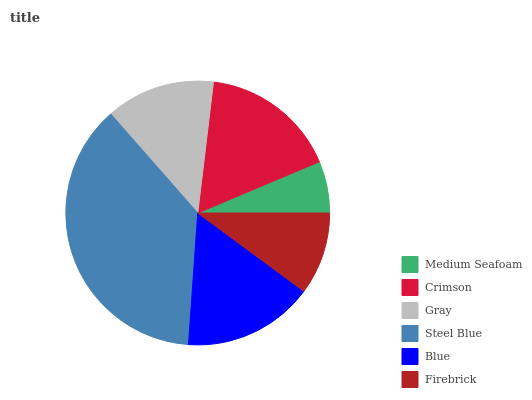Is Medium Seafoam the minimum?
Answer yes or no. Yes. Is Steel Blue the maximum?
Answer yes or no. Yes. Is Crimson the minimum?
Answer yes or no. No. Is Crimson the maximum?
Answer yes or no. No. Is Crimson greater than Medium Seafoam?
Answer yes or no. Yes. Is Medium Seafoam less than Crimson?
Answer yes or no. Yes. Is Medium Seafoam greater than Crimson?
Answer yes or no. No. Is Crimson less than Medium Seafoam?
Answer yes or no. No. Is Blue the high median?
Answer yes or no. Yes. Is Gray the low median?
Answer yes or no. Yes. Is Crimson the high median?
Answer yes or no. No. Is Steel Blue the low median?
Answer yes or no. No. 